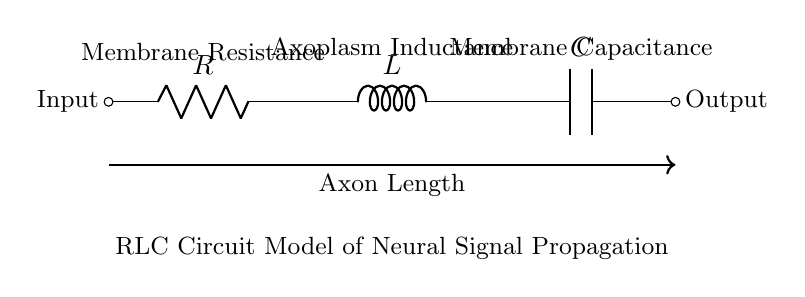What are the three components in this circuit? The circuit diagram shows a resistor, an inductor, and a capacitor. These are represented as R, L, and C in the diagram.
Answer: Resistor, Inductor, Capacitor What is the role of the resistor in this circuit? The resistor's role is to provide resistance to the flow of neural signals, simulating membrane resistance in axons. This affects the rate of signal propagation due to the resistive dissipation of energy.
Answer: Membrane Resistance What does the inductor represent in the context of neural signal propagation? The inductor represents the inductance of the axoplasm, which is the cytoplasm within the axon. It is involved in the delay of current due to changes in the magnetic field associated with the flowing neural signals.
Answer: Axoplasm Inductance If the resistance is increased, what effect will this have on the signal propagation? Increasing resistance will decrease the current and potentially slow down the rate of signal propagation, as it introduces more energy loss in the form of heat. This happens due to Ohm's Law, which shows that higher resistance decreases current for a given voltage.
Answer: Slower propagation What happens to the signal if the capacitance is increased? Increasing capacitance allows the axon to store more charge, which can lead to a greater current flow during signal transmission and can enhance the efficiency of signal propagation, allowing for quicker transitions during signal changes.
Answer: Greater current flow 